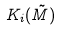Convert formula to latex. <formula><loc_0><loc_0><loc_500><loc_500>K _ { i } ( \tilde { M } )</formula> 